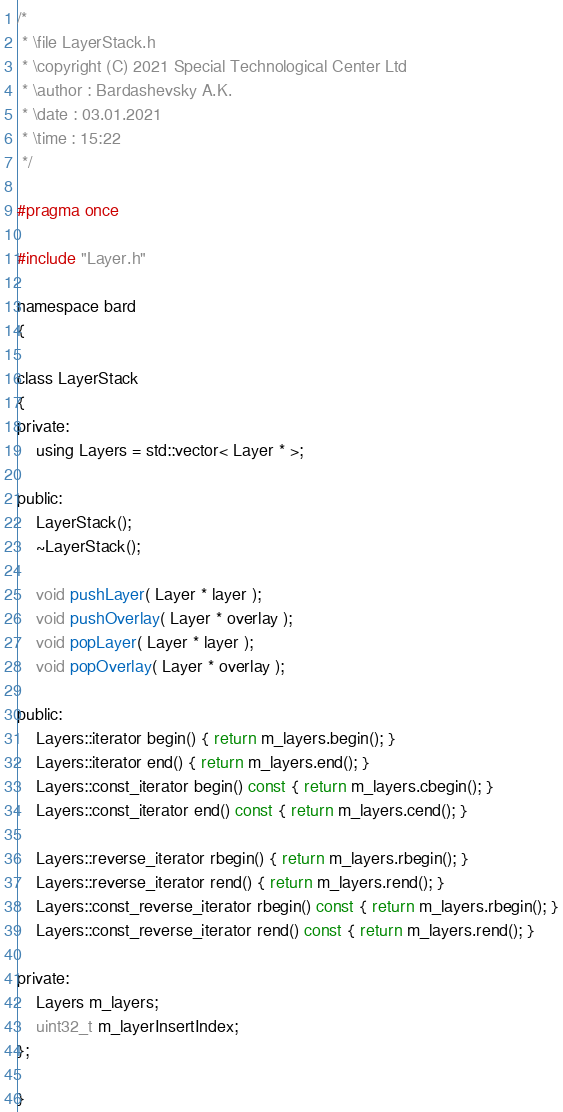<code> <loc_0><loc_0><loc_500><loc_500><_C_>/*
 * \file LayerStack.h
 * \copyright (C) 2021 Special Technological Center Ltd
 * \author : Bardashevsky A.K.
 * \date : 03.01.2021
 * \time : 15:22
 */

#pragma once

#include "Layer.h"

namespace bard
{

class LayerStack
{
private:
    using Layers = std::vector< Layer * >;

public:
    LayerStack();
    ~LayerStack();

    void pushLayer( Layer * layer );
    void pushOverlay( Layer * overlay );
    void popLayer( Layer * layer );
    void popOverlay( Layer * overlay );

public:
    Layers::iterator begin() { return m_layers.begin(); }
    Layers::iterator end() { return m_layers.end(); }
    Layers::const_iterator begin() const { return m_layers.cbegin(); }
    Layers::const_iterator end() const { return m_layers.cend(); }

    Layers::reverse_iterator rbegin() { return m_layers.rbegin(); }
    Layers::reverse_iterator rend() { return m_layers.rend(); }
    Layers::const_reverse_iterator rbegin() const { return m_layers.rbegin(); }
    Layers::const_reverse_iterator rend() const { return m_layers.rend(); }

private:
    Layers m_layers;
    uint32_t m_layerInsertIndex;
};

}
</code> 